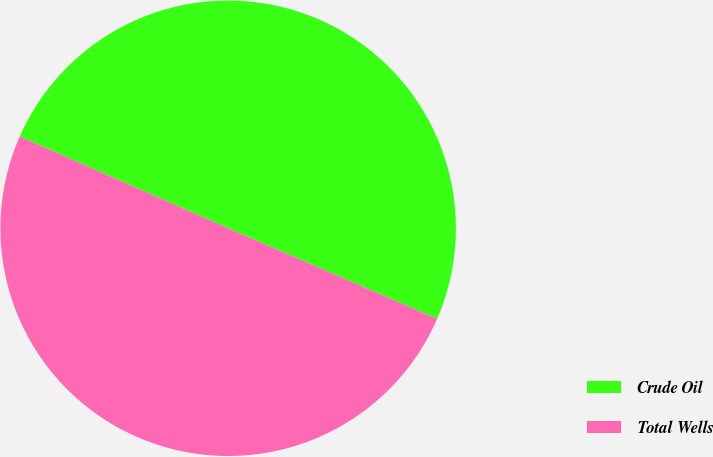Convert chart. <chart><loc_0><loc_0><loc_500><loc_500><pie_chart><fcel>Crude Oil<fcel>Total Wells<nl><fcel>49.9%<fcel>50.1%<nl></chart> 